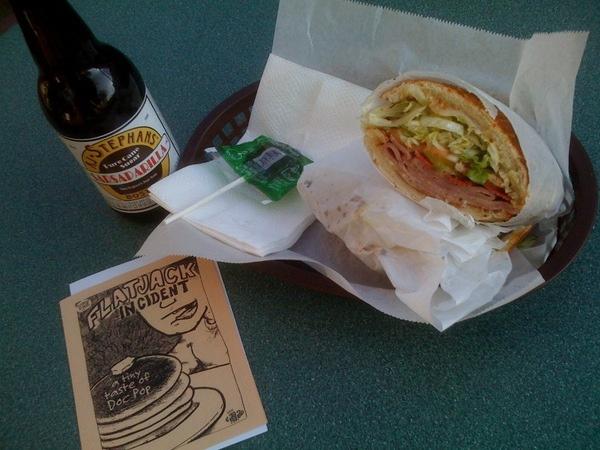Can you see pancakes?
Write a very short answer. Yes. What brand of beer is it?
Quick response, please. Stephens. What color is the counter?
Short answer required. Green. 